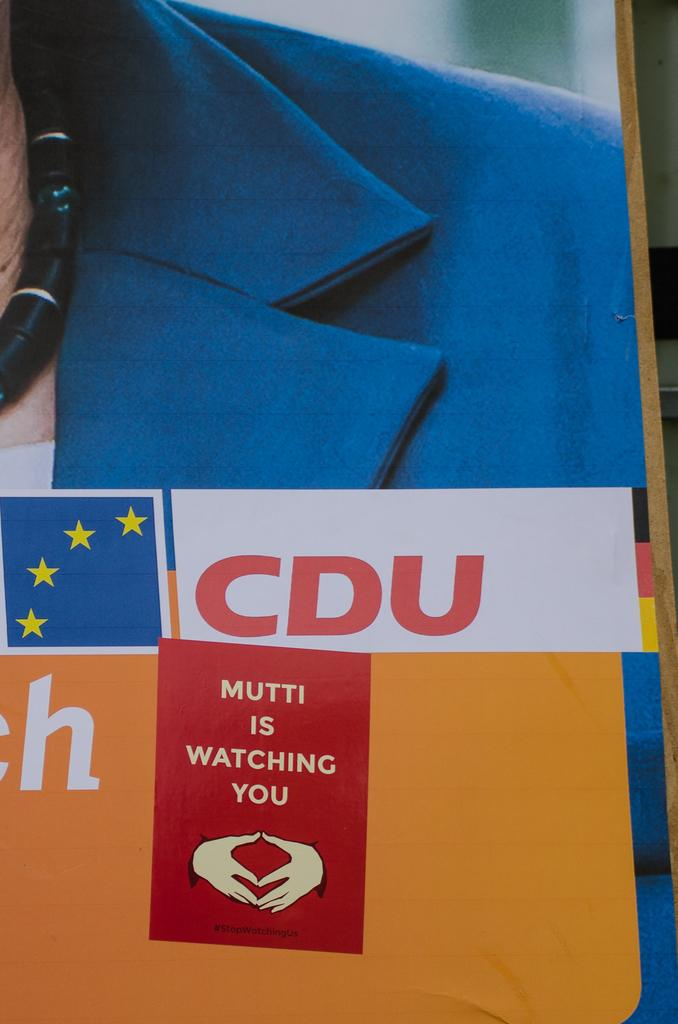What is on the board in the image? There is a poster on a board in the image. Who is featured on the poster? The poster features a man. What is the man wearing? The man is wearing a blue suit. What else can be seen on the poster besides the man? There is text at the bottom of the poster. How many eyes can be seen on the bridge in the image? There is no bridge present in the image, and therefore no eyes can be seen on a bridge. 